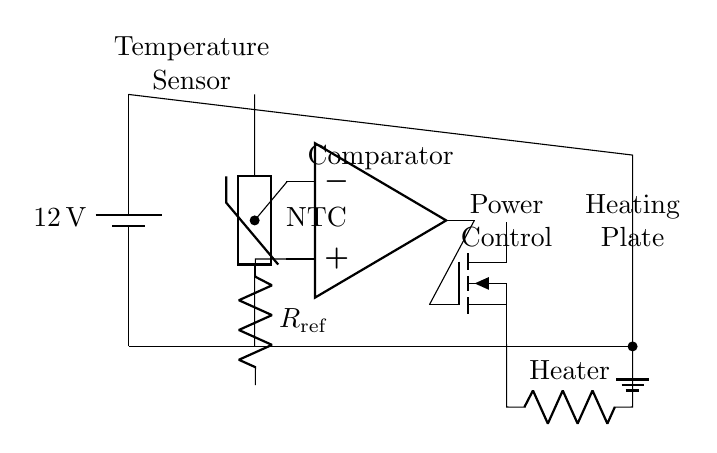What is the type of temperature sensor used in this circuit? The circuit displays a labeled thermistor, indicating that this temperature sensor is an NTC thermistor, commonly used for temperature measurements due to its resistance change with temperature.
Answer: NTC thermistor What voltage does the power supply provide? The power supply in the circuit is labeled as twelve volts, indicating that it provides a potential difference of twelve volts to power the circuit.
Answer: twelve volts What component controls the heating element? The MOSFET is directly connected to the operational amplifier's output, which indicates that it is responsible for controlling the power delivered to the heating element based on the temperature inputs.
Answer: MOSFET What is the function of the operational amplifier in this circuit? The operational amplifier is implemented as a comparator to compare the reference voltage from the resistor with the voltage from the temperature sensor, which decides whether to activate or deactivate the heating element.
Answer: Comparator How is the heating element connected in the circuit? The heating element is connected to the source of the MOSFET, and it returns to the positive terminal of the battery, forming a complete circuit for current to flow through the heating element.
Answer: In series with MOSFET What type of feedback is likely happening in this circuit? The thermistor provides a feedback mechanism to the operational amplifier, creating a control loop where the amplifier continuously adjusts the MOSFET's gate voltage to maintain the desired temperature.
Answer: Negative feedback What role does the reference resistor play in this circuit? The reference resistor sets a voltage level against which the operational amplifier compares the voltage from the thermistor, determining whether the heating element should be turned on or off.
Answer: Voltage reference 